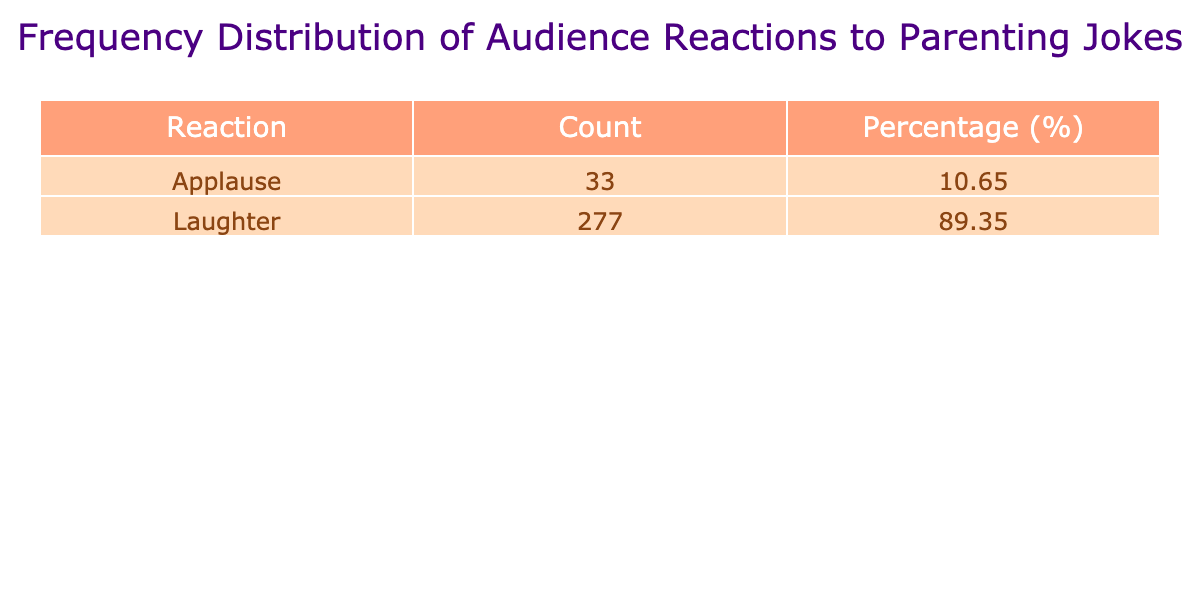What is the total count of audience reactions recorded in the table? To find the total count, I will sum the Count values for each reaction type. The counts are: 25 (Laughter) + 30 (Laughter) + 20 (Laughter) + 22 (Laughter) + 18 (Applause) + 40 (Laughter) + 36 (Laughter) + 12 (Laughter) + 27 (Laughter) + 10 (Laughter) + 20 (Laughter) + 35 (Laughter) + 15 (Applause) =  365.
Answer: 365 How many reactions were categorized as "Applause"? From the table, I will look for the rows where the Reaction type is "Applause." There are two entries for Applause: one with a count of 18 and another with a count of 15. Therefore, I will add these two counts: 18 + 15 = 33.
Answer: 33 What reaction had the highest count and what was that count? I will compare the Count values for all reactions. The reactions and counts are: 25 (Laughter), 30 (Laughter), 20 (Laughter), 22 (Laughter), 18 (Applause), 40 (Laughter), 36 (Laughter), 12 (Laughter), 27 (Laughter), 10 (Laughter), 20 (Laughter), 35 (Laughter), and 15 (Applause). The highest count is 40 for the reaction "Mommy drinks because I cry."
Answer: 40 What percentage of total reactions were "Laughter"? First, I need to calculate the total count of "Laughter" reactions: 25 + 30 + 20 + 22 + 40 + 36 + 12 + 27 + 10 + 20 + 35 =  307. Then, the percentage of Laughter reactions is calculated by dividing the total Laughter count by the overall total (365) and multiplying by 100: (307 / 365) * 100 = 84.16%.
Answer: 84.16 Is it true that "Applause" received a total higher count than "Silence"? Looking at the table, there are counts recorded for "Applause," which is 33 (18 + 15). However, there are no entries for "Silence," meaning the count is 0. Thus, Applause is greater than Silence in count.
Answer: Yes What is the average count of each reaction type? I will sum the counts for each reaction type: for Laughter it is 307; for Applause, it is 33. Then I divide each total by the number of entries in the respective category: Laughter has 11 entries (307/11 = 27.91) and Applause has 2 entries (33/2 = 16.5). Thus, the averages are 27.91 for Laughter and 16.5 for Applause.
Answer: Laughter: 27.91, Applause: 16.5 How many more laughter reactions were there compared to applause reactions? I have already calculated the total counts for each reaction type: Laughter is 307 and Applause is 33. To find the difference, I will subtract the Count of Applause from the Count of Laughter: 307 - 33 = 274.
Answer: 274 Are there more reactions with laughter than applause combined? The total for "Applause" is 33. The total for "Laughter," on the other hand, is 307. When I combine the counts of Applause (33) and Laughter (307), I compare 307 + 33 = 340, which is certainly more than Applause alone.
Answer: Yes 